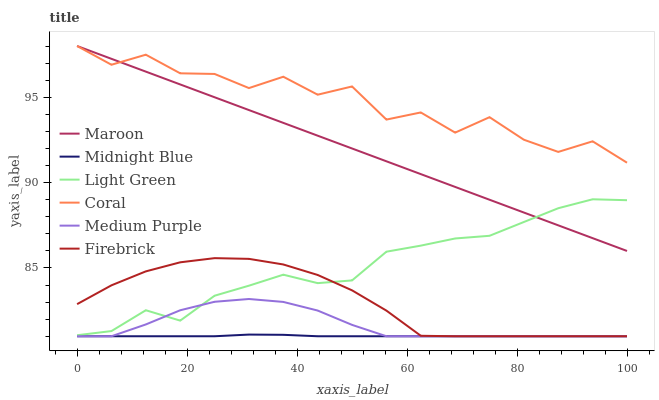Does Firebrick have the minimum area under the curve?
Answer yes or no. No. Does Firebrick have the maximum area under the curve?
Answer yes or no. No. Is Firebrick the smoothest?
Answer yes or no. No. Is Firebrick the roughest?
Answer yes or no. No. Does Maroon have the lowest value?
Answer yes or no. No. Does Firebrick have the highest value?
Answer yes or no. No. Is Midnight Blue less than Maroon?
Answer yes or no. Yes. Is Maroon greater than Midnight Blue?
Answer yes or no. Yes. Does Midnight Blue intersect Maroon?
Answer yes or no. No. 